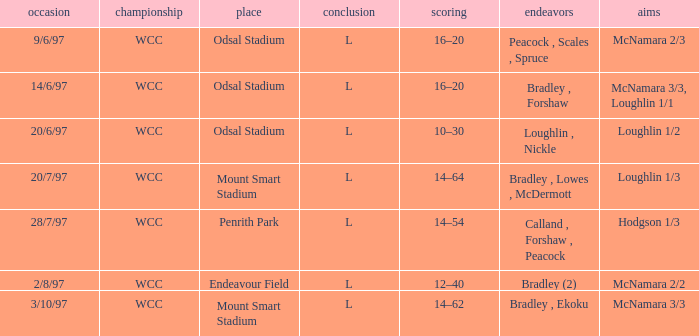Can you provide the score for the game on 20th june 1997? 10–30. 